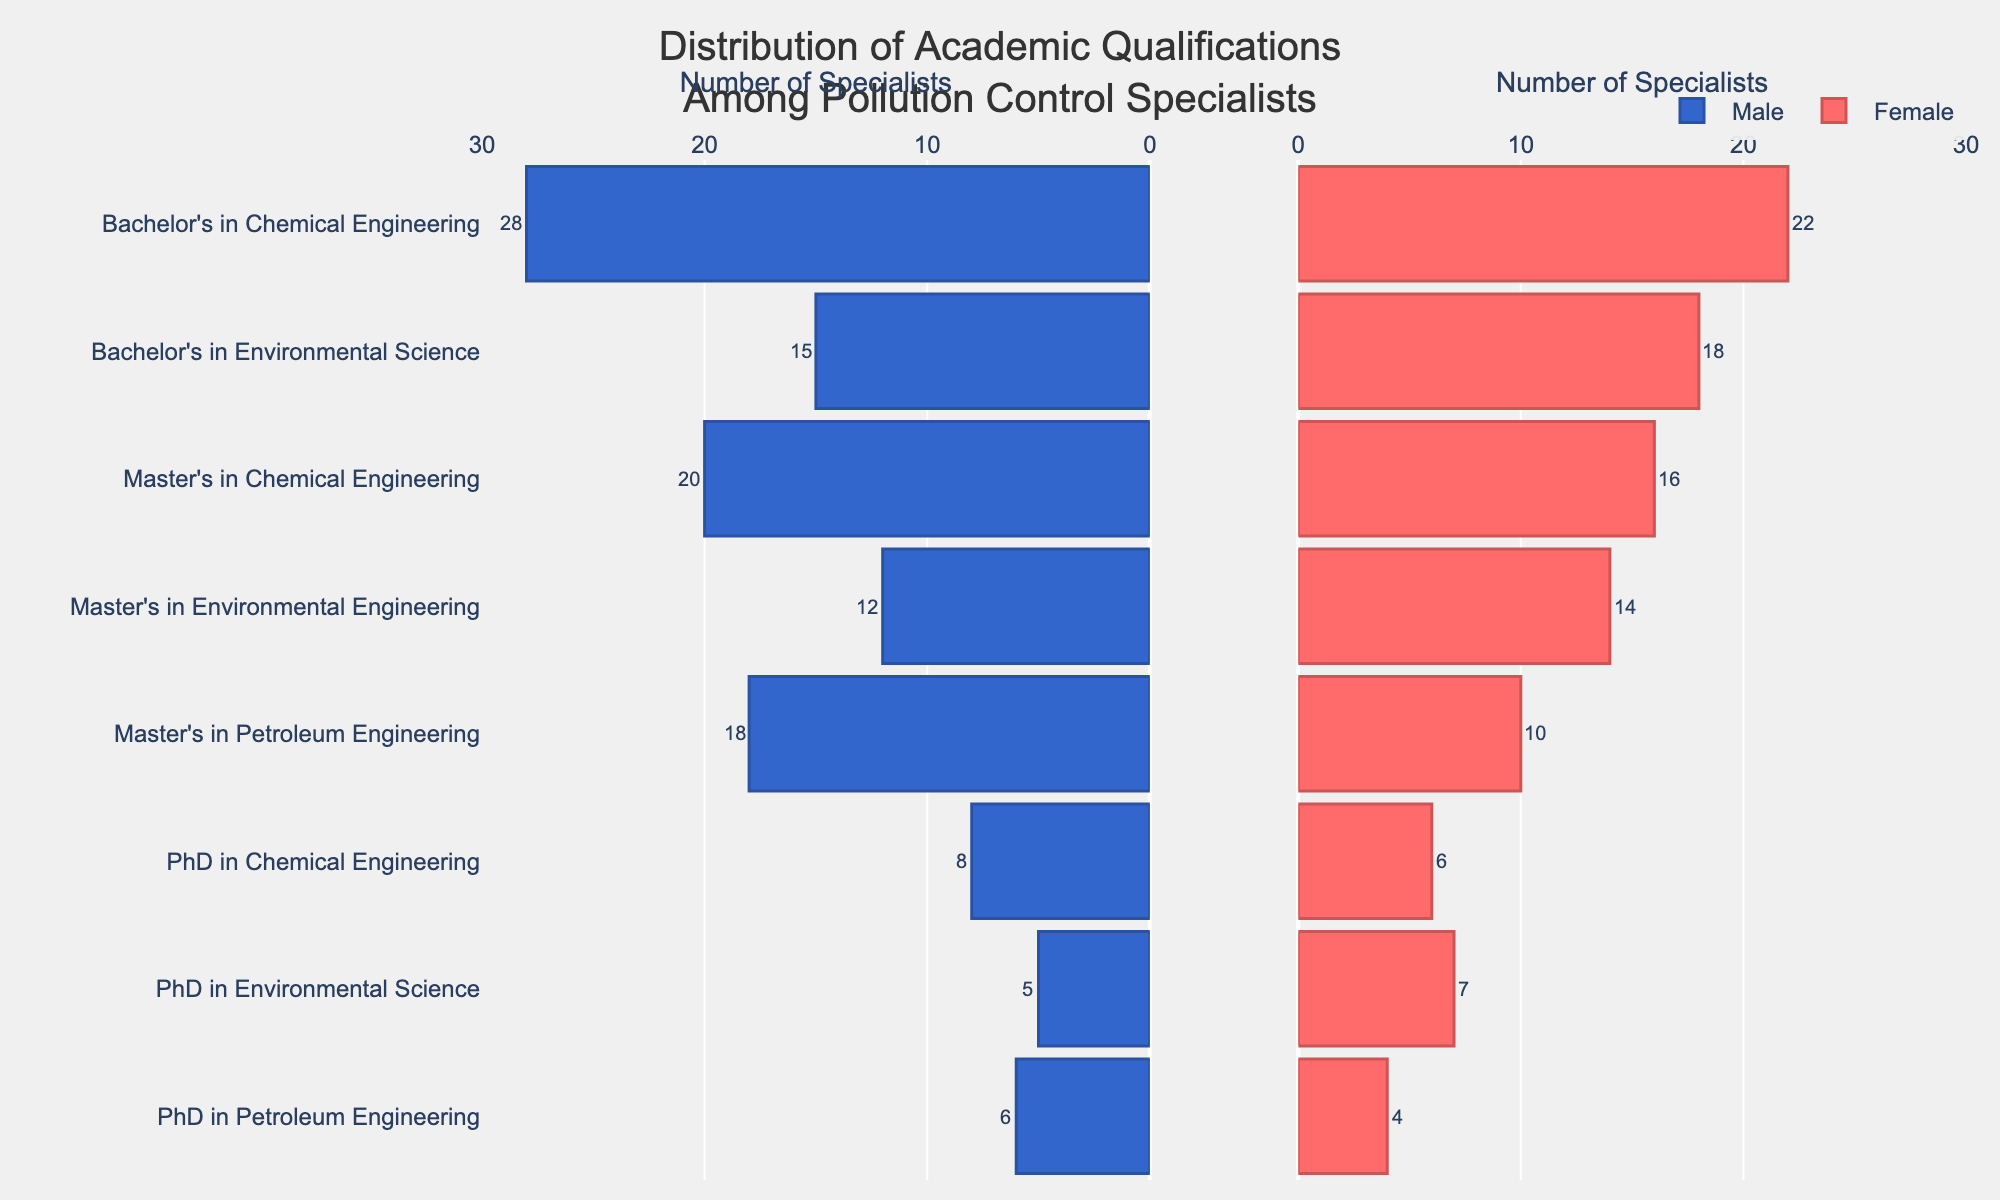What's the title of the figure? The title is located at the top of the figure and typically provides a concise description of what the figure represents. In this case, the title reads "Distribution of Academic Qualifications Among Pollution Control Specialists."
Answer: Distribution of Academic Qualifications Among Pollution Control Specialists How many qualifications are listed in the figure? Count the number of distinct qualifications listed along the y-axis of the figure. There are 8 qualifications.
Answer: 8 Which qualification has the highest number of male specialists? To determine this, compare the values of the male bars for each qualification. The highest number of male specialists is for "Bachelor's in Chemical Engineering" with 28 specialists.
Answer: Bachelor's in Chemical Engineering Which qualification has the smallest difference in the number of male and female specialists? Calculate the absolute difference between the number of male and female specialists for each qualification. The smallest difference is for "PhD in Environmental Science" with a difference of 2 specialists (5 males and 7 females).
Answer: PhD in Environmental Science What is the total number of male specialists with a PhD? Sum the number of male specialists for all PhD qualifications: 8 (Chemical Engineering) + 5 (Environmental Science) + 6 (Petroleum Engineering) = 19.
Answer: 19 Which gender has more specialists in "Master's in Environmental Engineering"? Compare the number of male and female specialists for "Master's in Environmental Engineering". There are 12 male specialists and 14 female specialists, so females have more specialists.
Answer: Female Among the qualifications listed, which one has the highest total number of specialists combining both genders? Sum the male and female specialists for each qualification. "Bachelor's in Chemical Engineering" has the highest total with 28 males + 22 females = 50 specialists.
Answer: Bachelor's in Chemical Engineering On average, how many specialists are there per listed qualification? Calculate the total number of specialists for all qualifications: ((28+22) + (15+18) + (20+16) + (12+14) + (18+10) + (8+6) + (5+7) + (6+4) = 189 specialists). Divide this sum by the number of qualifications (8): 189 / 8 = 23.625.
Answer: 23.625 What is the range of the number of female specialists in the given qualifications? Identify the maximum and minimum number of female specialists across all qualifications. The range is 22 (maximum in Bachelor's in Chemical Engineering) - 4 (minimum in PhD in Petroleum Engineering) = 18.
Answer: 18 Which qualification has an equal or closest number of male and female specialists? Compute the absolute difference between male and female specialists for each qualification. The closest numbers are in "PhD in Environmental Science" with 5 males and 7 females, making the difference 2.
Answer: PhD in Environmental Science 